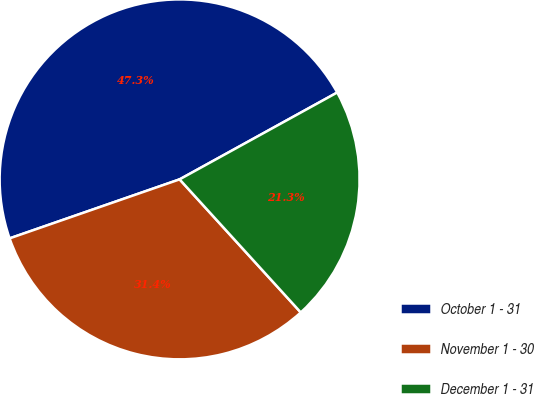Convert chart to OTSL. <chart><loc_0><loc_0><loc_500><loc_500><pie_chart><fcel>October 1 - 31<fcel>November 1 - 30<fcel>December 1 - 31<nl><fcel>47.3%<fcel>31.44%<fcel>21.26%<nl></chart> 